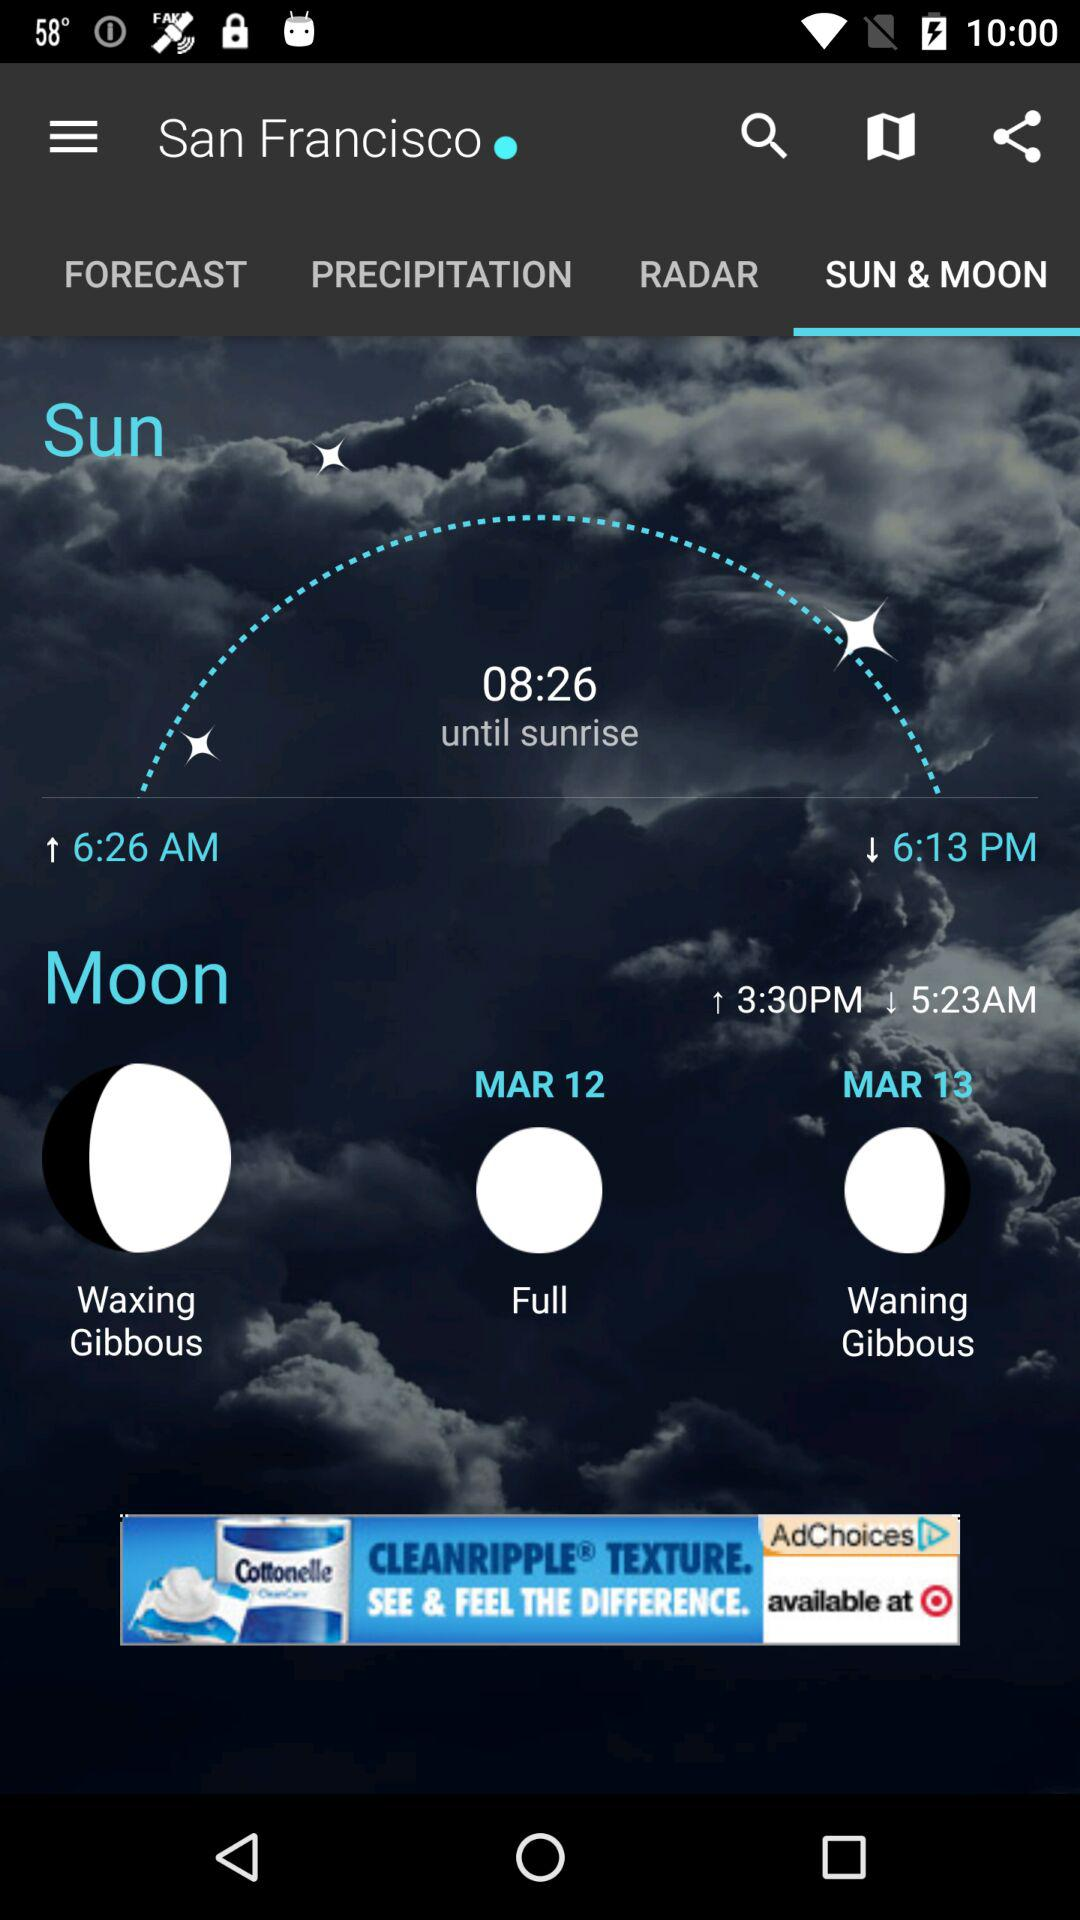On what date will the full moon occur? The full moon will occur on March 12. 